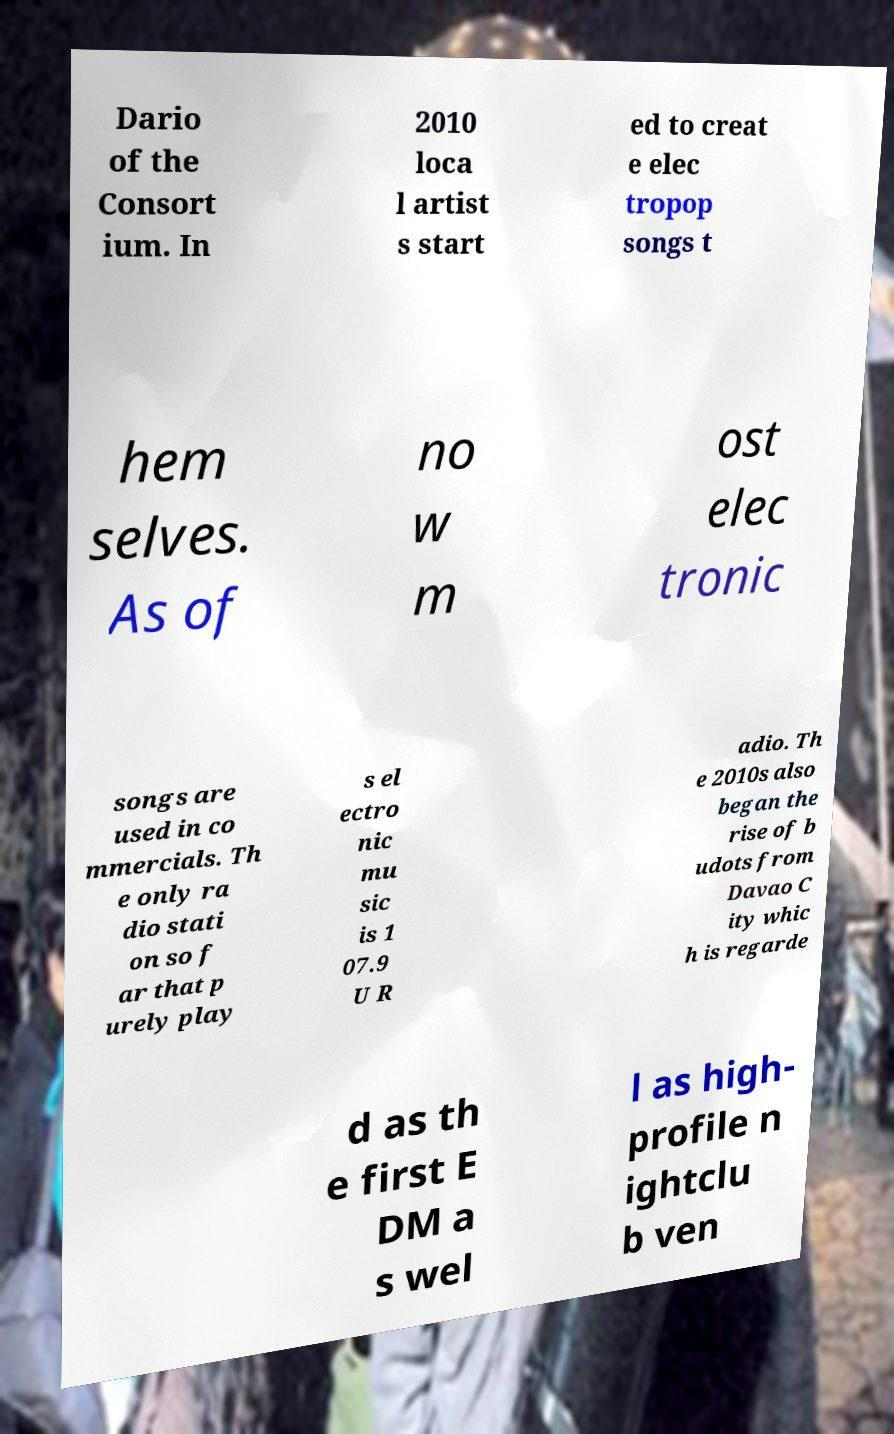Can you read and provide the text displayed in the image?This photo seems to have some interesting text. Can you extract and type it out for me? Dario of the Consort ium. In 2010 loca l artist s start ed to creat e elec tropop songs t hem selves. As of no w m ost elec tronic songs are used in co mmercials. Th e only ra dio stati on so f ar that p urely play s el ectro nic mu sic is 1 07.9 U R adio. Th e 2010s also began the rise of b udots from Davao C ity whic h is regarde d as th e first E DM a s wel l as high- profile n ightclu b ven 